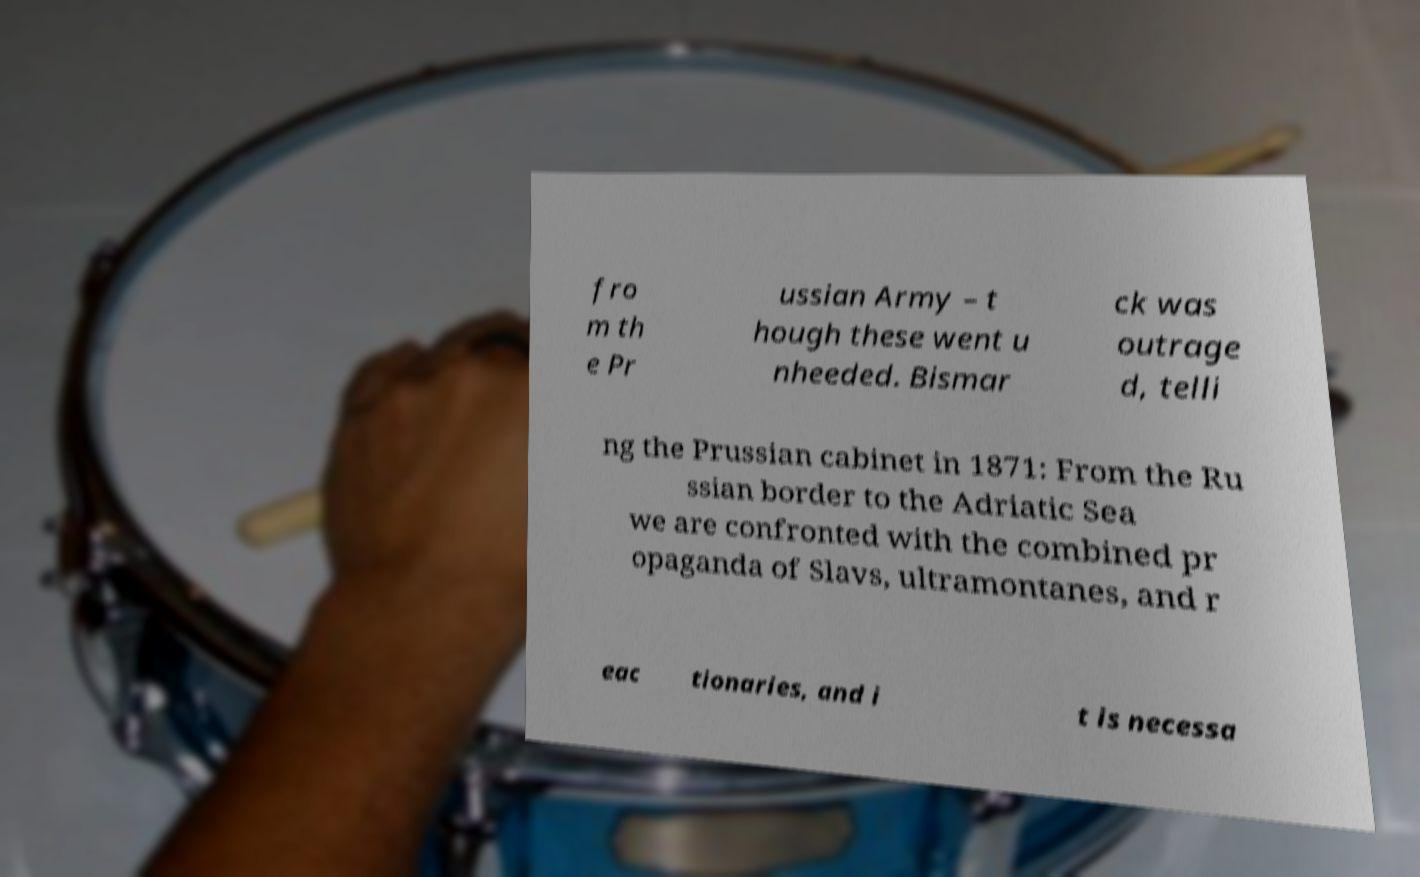Could you assist in decoding the text presented in this image and type it out clearly? fro m th e Pr ussian Army – t hough these went u nheeded. Bismar ck was outrage d, telli ng the Prussian cabinet in 1871: From the Ru ssian border to the Adriatic Sea we are confronted with the combined pr opaganda of Slavs, ultramontanes, and r eac tionaries, and i t is necessa 